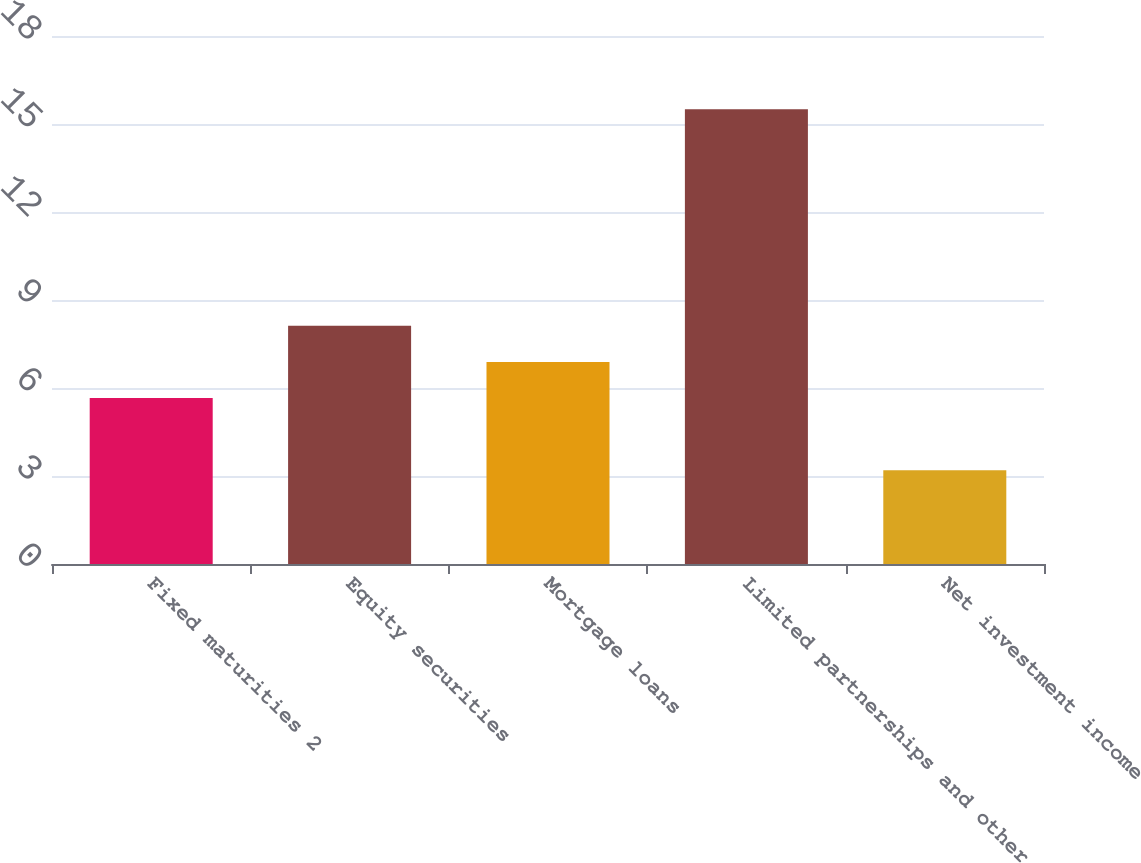Convert chart. <chart><loc_0><loc_0><loc_500><loc_500><bar_chart><fcel>Fixed maturities 2<fcel>Equity securities<fcel>Mortgage loans<fcel>Limited partnerships and other<fcel>Net investment income<nl><fcel>5.66<fcel>8.12<fcel>6.89<fcel>15.5<fcel>3.2<nl></chart> 